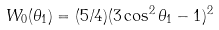<formula> <loc_0><loc_0><loc_500><loc_500>W _ { 0 } ( \theta _ { 1 } ) = ( 5 / 4 ) ( 3 \cos ^ { 2 } \theta _ { 1 } - 1 ) ^ { 2 }</formula> 